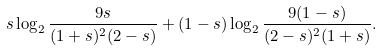Convert formula to latex. <formula><loc_0><loc_0><loc_500><loc_500>s \log _ { 2 } \frac { 9 s } { ( 1 + s ) ^ { 2 } ( 2 - s ) } + ( 1 - s ) \log _ { 2 } \frac { 9 ( 1 - s ) } { ( 2 - s ) ^ { 2 } ( 1 + s ) } .</formula> 